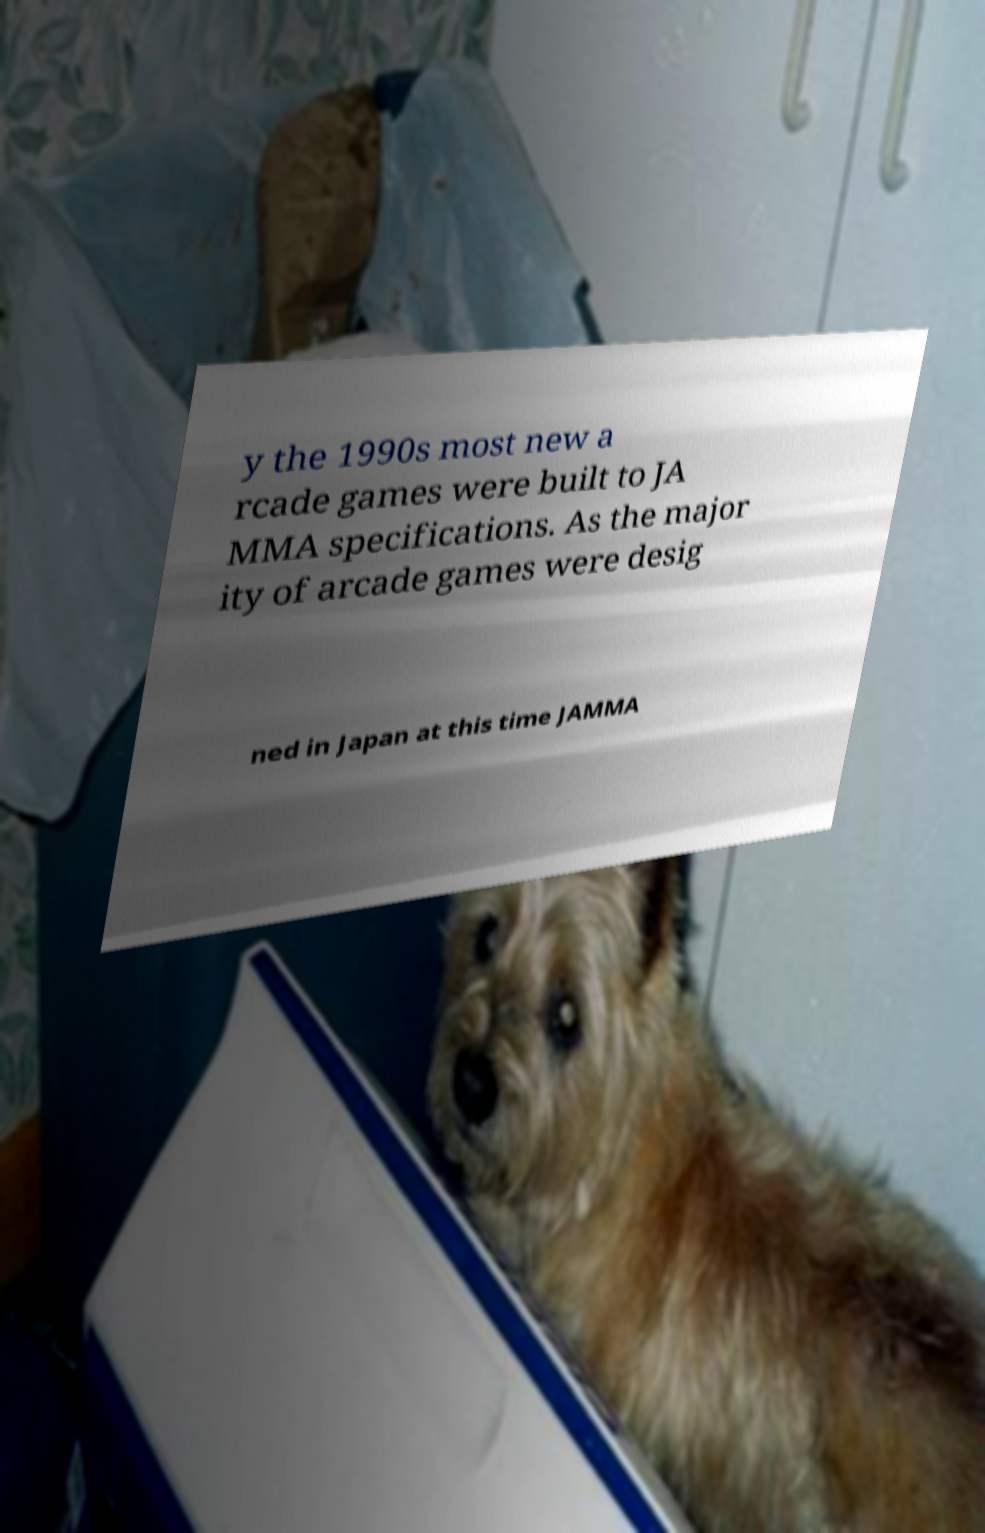Please read and relay the text visible in this image. What does it say? y the 1990s most new a rcade games were built to JA MMA specifications. As the major ity of arcade games were desig ned in Japan at this time JAMMA 